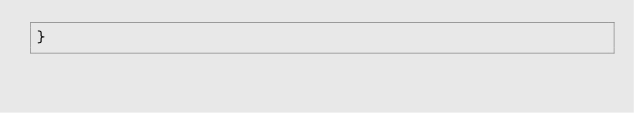<code> <loc_0><loc_0><loc_500><loc_500><_Scala_>}
</code> 